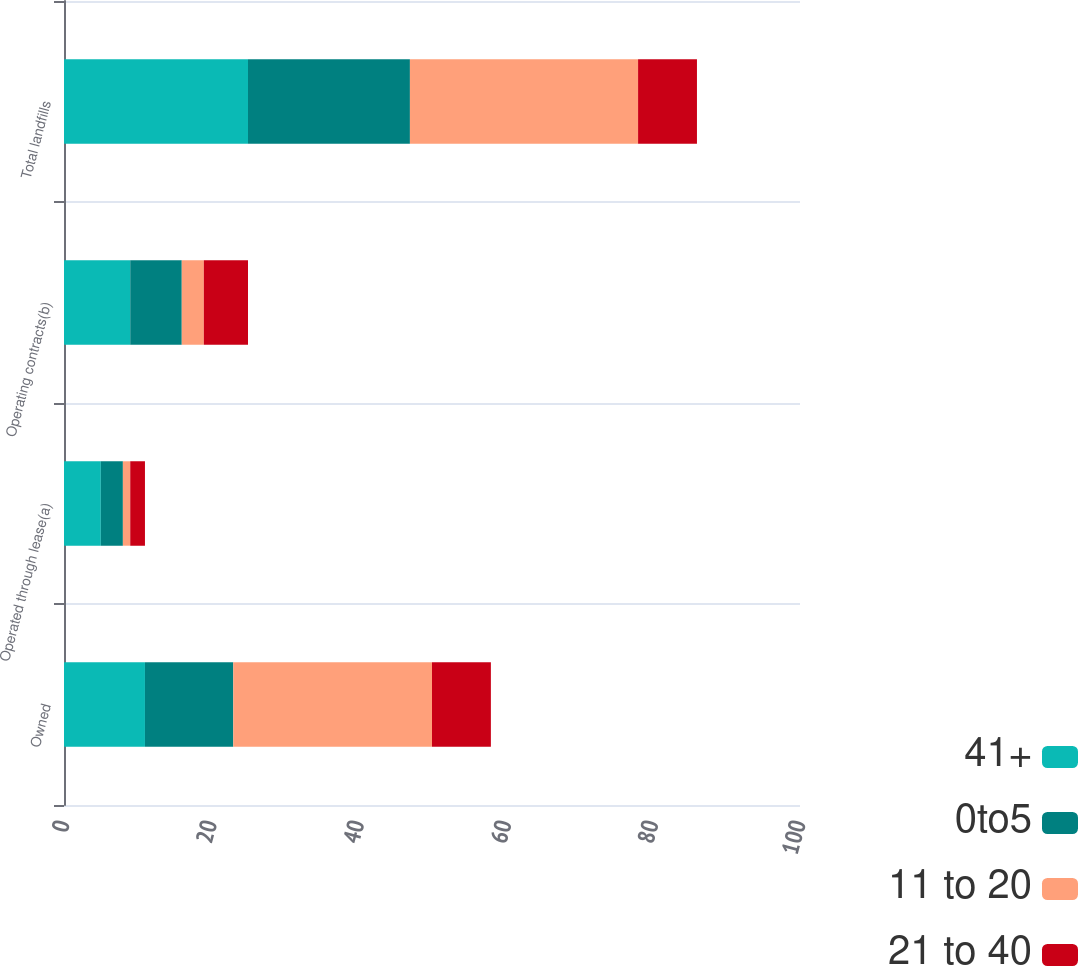Convert chart. <chart><loc_0><loc_0><loc_500><loc_500><stacked_bar_chart><ecel><fcel>Owned<fcel>Operated through lease(a)<fcel>Operating contracts(b)<fcel>Total landfills<nl><fcel>41+<fcel>11<fcel>5<fcel>9<fcel>25<nl><fcel>0to5<fcel>12<fcel>3<fcel>7<fcel>22<nl><fcel>11 to 20<fcel>27<fcel>1<fcel>3<fcel>31<nl><fcel>21 to 40<fcel>8<fcel>2<fcel>6<fcel>8<nl></chart> 